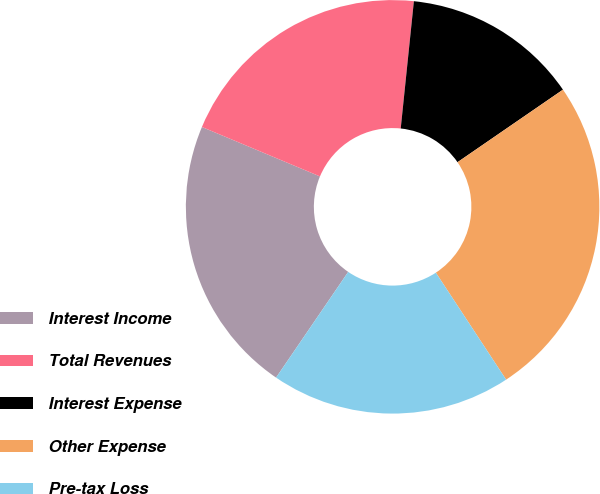Convert chart. <chart><loc_0><loc_0><loc_500><loc_500><pie_chart><fcel>Interest Income<fcel>Total Revenues<fcel>Interest Expense<fcel>Other Expense<fcel>Pre-tax Loss<nl><fcel>21.78%<fcel>20.33%<fcel>13.77%<fcel>25.34%<fcel>18.78%<nl></chart> 